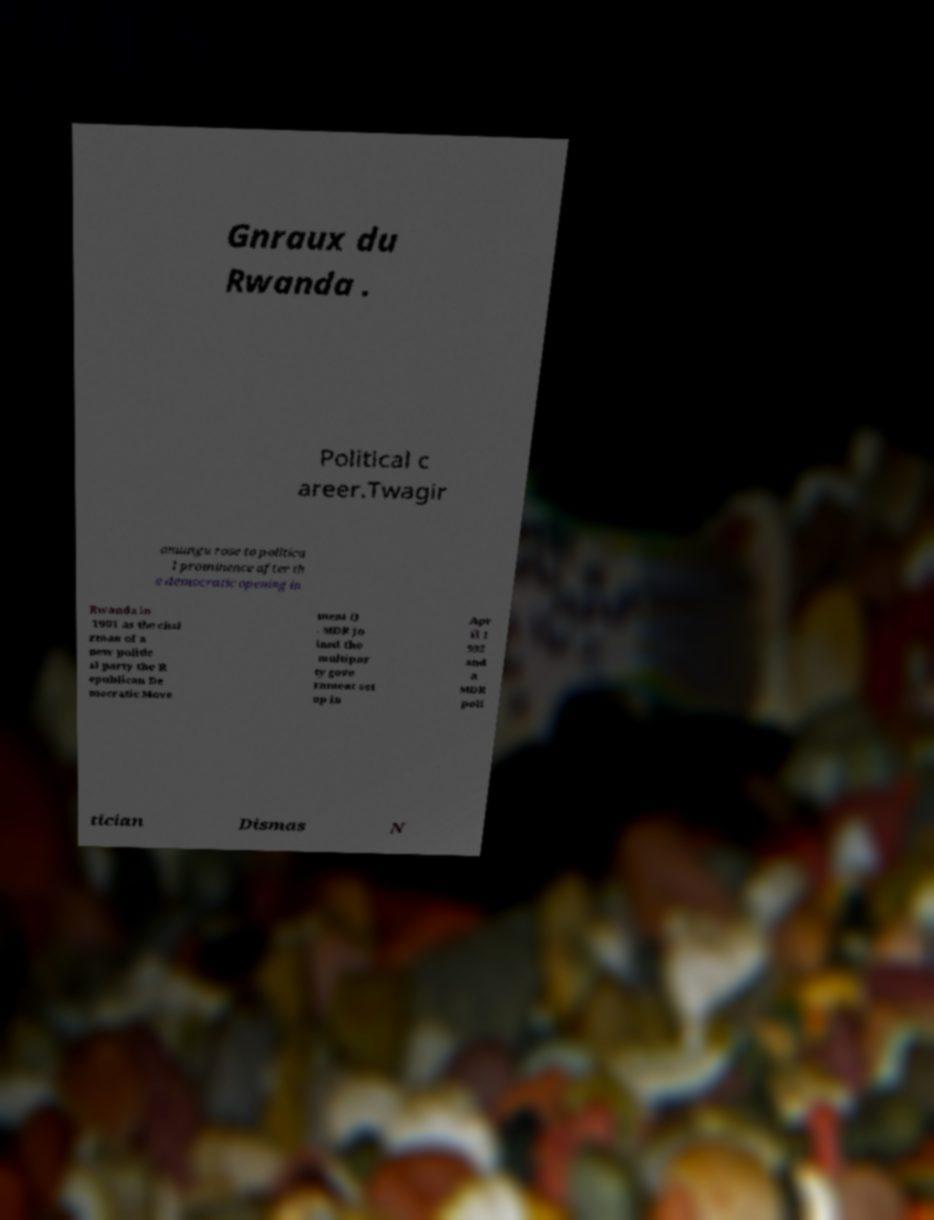Can you accurately transcribe the text from the provided image for me? Gnraux du Rwanda . Political c areer.Twagir amungu rose to politica l prominence after th e democratic opening in Rwanda in 1991 as the chai rman of a new politic al party the R epublican De mocratic Move ment () . MDR jo ined the multipar ty gove rnment set up in Apr il 1 992 and a MDR poli tician Dismas N 